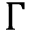<formula> <loc_0><loc_0><loc_500><loc_500>\Gamma</formula> 